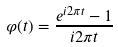<formula> <loc_0><loc_0><loc_500><loc_500>\varphi ( t ) = \frac { e ^ { i 2 \pi t } - 1 } { i 2 \pi t }</formula> 